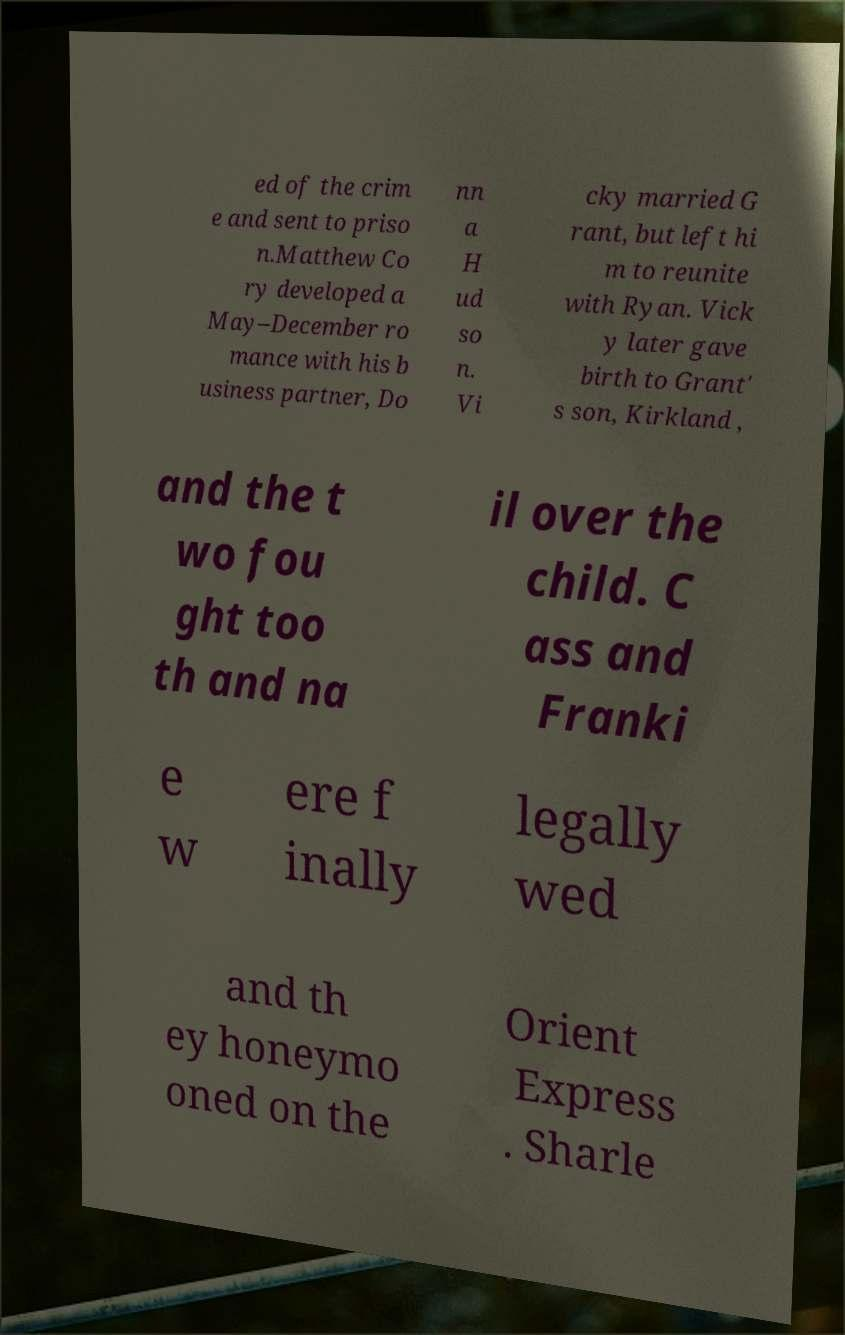There's text embedded in this image that I need extracted. Can you transcribe it verbatim? ed of the crim e and sent to priso n.Matthew Co ry developed a May–December ro mance with his b usiness partner, Do nn a H ud so n. Vi cky married G rant, but left hi m to reunite with Ryan. Vick y later gave birth to Grant' s son, Kirkland , and the t wo fou ght too th and na il over the child. C ass and Franki e w ere f inally legally wed and th ey honeymo oned on the Orient Express . Sharle 